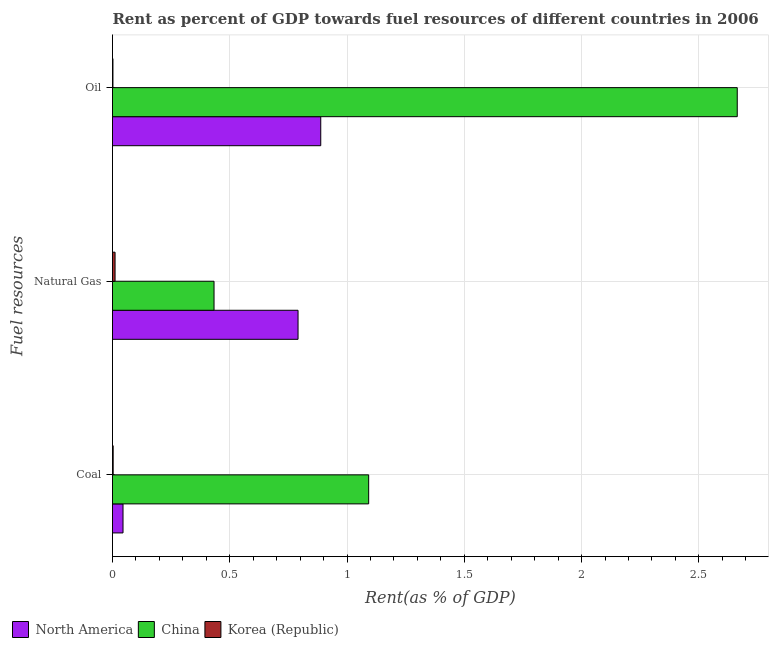How many different coloured bars are there?
Your answer should be very brief. 3. How many groups of bars are there?
Provide a short and direct response. 3. Are the number of bars per tick equal to the number of legend labels?
Your answer should be compact. Yes. What is the label of the 3rd group of bars from the top?
Offer a very short reply. Coal. What is the rent towards natural gas in China?
Your answer should be very brief. 0.43. Across all countries, what is the maximum rent towards coal?
Your response must be concise. 1.09. Across all countries, what is the minimum rent towards coal?
Your answer should be compact. 0. In which country was the rent towards oil maximum?
Your response must be concise. China. What is the total rent towards coal in the graph?
Make the answer very short. 1.14. What is the difference between the rent towards oil in China and that in Korea (Republic)?
Provide a short and direct response. 2.66. What is the difference between the rent towards coal in China and the rent towards natural gas in North America?
Give a very brief answer. 0.3. What is the average rent towards coal per country?
Provide a short and direct response. 0.38. What is the difference between the rent towards oil and rent towards coal in North America?
Offer a very short reply. 0.84. In how many countries, is the rent towards oil greater than 0.7 %?
Give a very brief answer. 2. What is the ratio of the rent towards coal in China to that in North America?
Your answer should be compact. 24.37. Is the rent towards oil in China less than that in Korea (Republic)?
Offer a terse response. No. What is the difference between the highest and the second highest rent towards oil?
Your response must be concise. 1.78. What is the difference between the highest and the lowest rent towards oil?
Provide a short and direct response. 2.66. What does the 2nd bar from the bottom in Natural Gas represents?
Offer a terse response. China. Is it the case that in every country, the sum of the rent towards coal and rent towards natural gas is greater than the rent towards oil?
Give a very brief answer. No. How many bars are there?
Your answer should be very brief. 9. Are all the bars in the graph horizontal?
Provide a short and direct response. Yes. How many countries are there in the graph?
Provide a succinct answer. 3. Are the values on the major ticks of X-axis written in scientific E-notation?
Provide a succinct answer. No. Where does the legend appear in the graph?
Keep it short and to the point. Bottom left. What is the title of the graph?
Offer a very short reply. Rent as percent of GDP towards fuel resources of different countries in 2006. What is the label or title of the X-axis?
Provide a succinct answer. Rent(as % of GDP). What is the label or title of the Y-axis?
Provide a succinct answer. Fuel resources. What is the Rent(as % of GDP) of North America in Coal?
Keep it short and to the point. 0.04. What is the Rent(as % of GDP) of China in Coal?
Your answer should be very brief. 1.09. What is the Rent(as % of GDP) in Korea (Republic) in Coal?
Your response must be concise. 0. What is the Rent(as % of GDP) in North America in Natural Gas?
Offer a terse response. 0.79. What is the Rent(as % of GDP) in China in Natural Gas?
Provide a short and direct response. 0.43. What is the Rent(as % of GDP) of Korea (Republic) in Natural Gas?
Your response must be concise. 0.01. What is the Rent(as % of GDP) in North America in Oil?
Your response must be concise. 0.89. What is the Rent(as % of GDP) of China in Oil?
Make the answer very short. 2.66. What is the Rent(as % of GDP) of Korea (Republic) in Oil?
Make the answer very short. 0. Across all Fuel resources, what is the maximum Rent(as % of GDP) in North America?
Your answer should be compact. 0.89. Across all Fuel resources, what is the maximum Rent(as % of GDP) in China?
Your response must be concise. 2.66. Across all Fuel resources, what is the maximum Rent(as % of GDP) of Korea (Republic)?
Your answer should be very brief. 0.01. Across all Fuel resources, what is the minimum Rent(as % of GDP) in North America?
Provide a short and direct response. 0.04. Across all Fuel resources, what is the minimum Rent(as % of GDP) in China?
Offer a very short reply. 0.43. Across all Fuel resources, what is the minimum Rent(as % of GDP) of Korea (Republic)?
Make the answer very short. 0. What is the total Rent(as % of GDP) in North America in the graph?
Offer a very short reply. 1.72. What is the total Rent(as % of GDP) in China in the graph?
Keep it short and to the point. 4.19. What is the total Rent(as % of GDP) of Korea (Republic) in the graph?
Your answer should be compact. 0.02. What is the difference between the Rent(as % of GDP) of North America in Coal and that in Natural Gas?
Your answer should be very brief. -0.75. What is the difference between the Rent(as % of GDP) in China in Coal and that in Natural Gas?
Offer a terse response. 0.66. What is the difference between the Rent(as % of GDP) of Korea (Republic) in Coal and that in Natural Gas?
Keep it short and to the point. -0.01. What is the difference between the Rent(as % of GDP) of North America in Coal and that in Oil?
Offer a very short reply. -0.84. What is the difference between the Rent(as % of GDP) of China in Coal and that in Oil?
Keep it short and to the point. -1.57. What is the difference between the Rent(as % of GDP) in Korea (Republic) in Coal and that in Oil?
Give a very brief answer. 0. What is the difference between the Rent(as % of GDP) of North America in Natural Gas and that in Oil?
Give a very brief answer. -0.1. What is the difference between the Rent(as % of GDP) of China in Natural Gas and that in Oil?
Your answer should be very brief. -2.23. What is the difference between the Rent(as % of GDP) of Korea (Republic) in Natural Gas and that in Oil?
Ensure brevity in your answer.  0.01. What is the difference between the Rent(as % of GDP) in North America in Coal and the Rent(as % of GDP) in China in Natural Gas?
Offer a very short reply. -0.39. What is the difference between the Rent(as % of GDP) of North America in Coal and the Rent(as % of GDP) of Korea (Republic) in Natural Gas?
Your answer should be very brief. 0.03. What is the difference between the Rent(as % of GDP) in China in Coal and the Rent(as % of GDP) in Korea (Republic) in Natural Gas?
Offer a terse response. 1.08. What is the difference between the Rent(as % of GDP) of North America in Coal and the Rent(as % of GDP) of China in Oil?
Ensure brevity in your answer.  -2.62. What is the difference between the Rent(as % of GDP) of North America in Coal and the Rent(as % of GDP) of Korea (Republic) in Oil?
Ensure brevity in your answer.  0.04. What is the difference between the Rent(as % of GDP) in China in Coal and the Rent(as % of GDP) in Korea (Republic) in Oil?
Offer a very short reply. 1.09. What is the difference between the Rent(as % of GDP) of North America in Natural Gas and the Rent(as % of GDP) of China in Oil?
Offer a very short reply. -1.87. What is the difference between the Rent(as % of GDP) of North America in Natural Gas and the Rent(as % of GDP) of Korea (Republic) in Oil?
Your answer should be compact. 0.79. What is the difference between the Rent(as % of GDP) in China in Natural Gas and the Rent(as % of GDP) in Korea (Republic) in Oil?
Give a very brief answer. 0.43. What is the average Rent(as % of GDP) in North America per Fuel resources?
Provide a succinct answer. 0.57. What is the average Rent(as % of GDP) in China per Fuel resources?
Your answer should be very brief. 1.4. What is the average Rent(as % of GDP) in Korea (Republic) per Fuel resources?
Give a very brief answer. 0.01. What is the difference between the Rent(as % of GDP) of North America and Rent(as % of GDP) of China in Coal?
Give a very brief answer. -1.05. What is the difference between the Rent(as % of GDP) of North America and Rent(as % of GDP) of Korea (Republic) in Coal?
Your response must be concise. 0.04. What is the difference between the Rent(as % of GDP) in China and Rent(as % of GDP) in Korea (Republic) in Coal?
Offer a terse response. 1.09. What is the difference between the Rent(as % of GDP) in North America and Rent(as % of GDP) in China in Natural Gas?
Provide a short and direct response. 0.36. What is the difference between the Rent(as % of GDP) of North America and Rent(as % of GDP) of Korea (Republic) in Natural Gas?
Provide a succinct answer. 0.78. What is the difference between the Rent(as % of GDP) in China and Rent(as % of GDP) in Korea (Republic) in Natural Gas?
Provide a succinct answer. 0.42. What is the difference between the Rent(as % of GDP) of North America and Rent(as % of GDP) of China in Oil?
Offer a very short reply. -1.78. What is the difference between the Rent(as % of GDP) of North America and Rent(as % of GDP) of Korea (Republic) in Oil?
Offer a terse response. 0.89. What is the difference between the Rent(as % of GDP) in China and Rent(as % of GDP) in Korea (Republic) in Oil?
Make the answer very short. 2.66. What is the ratio of the Rent(as % of GDP) in North America in Coal to that in Natural Gas?
Keep it short and to the point. 0.06. What is the ratio of the Rent(as % of GDP) of China in Coal to that in Natural Gas?
Provide a succinct answer. 2.52. What is the ratio of the Rent(as % of GDP) of Korea (Republic) in Coal to that in Natural Gas?
Keep it short and to the point. 0.26. What is the ratio of the Rent(as % of GDP) in North America in Coal to that in Oil?
Your response must be concise. 0.05. What is the ratio of the Rent(as % of GDP) in China in Coal to that in Oil?
Offer a terse response. 0.41. What is the ratio of the Rent(as % of GDP) of Korea (Republic) in Coal to that in Oil?
Offer a terse response. 1.49. What is the ratio of the Rent(as % of GDP) of North America in Natural Gas to that in Oil?
Your answer should be very brief. 0.89. What is the ratio of the Rent(as % of GDP) of China in Natural Gas to that in Oil?
Make the answer very short. 0.16. What is the ratio of the Rent(as % of GDP) of Korea (Republic) in Natural Gas to that in Oil?
Provide a succinct answer. 5.77. What is the difference between the highest and the second highest Rent(as % of GDP) of North America?
Offer a very short reply. 0.1. What is the difference between the highest and the second highest Rent(as % of GDP) in China?
Your response must be concise. 1.57. What is the difference between the highest and the second highest Rent(as % of GDP) in Korea (Republic)?
Provide a short and direct response. 0.01. What is the difference between the highest and the lowest Rent(as % of GDP) in North America?
Offer a terse response. 0.84. What is the difference between the highest and the lowest Rent(as % of GDP) of China?
Offer a very short reply. 2.23. What is the difference between the highest and the lowest Rent(as % of GDP) in Korea (Republic)?
Your answer should be very brief. 0.01. 